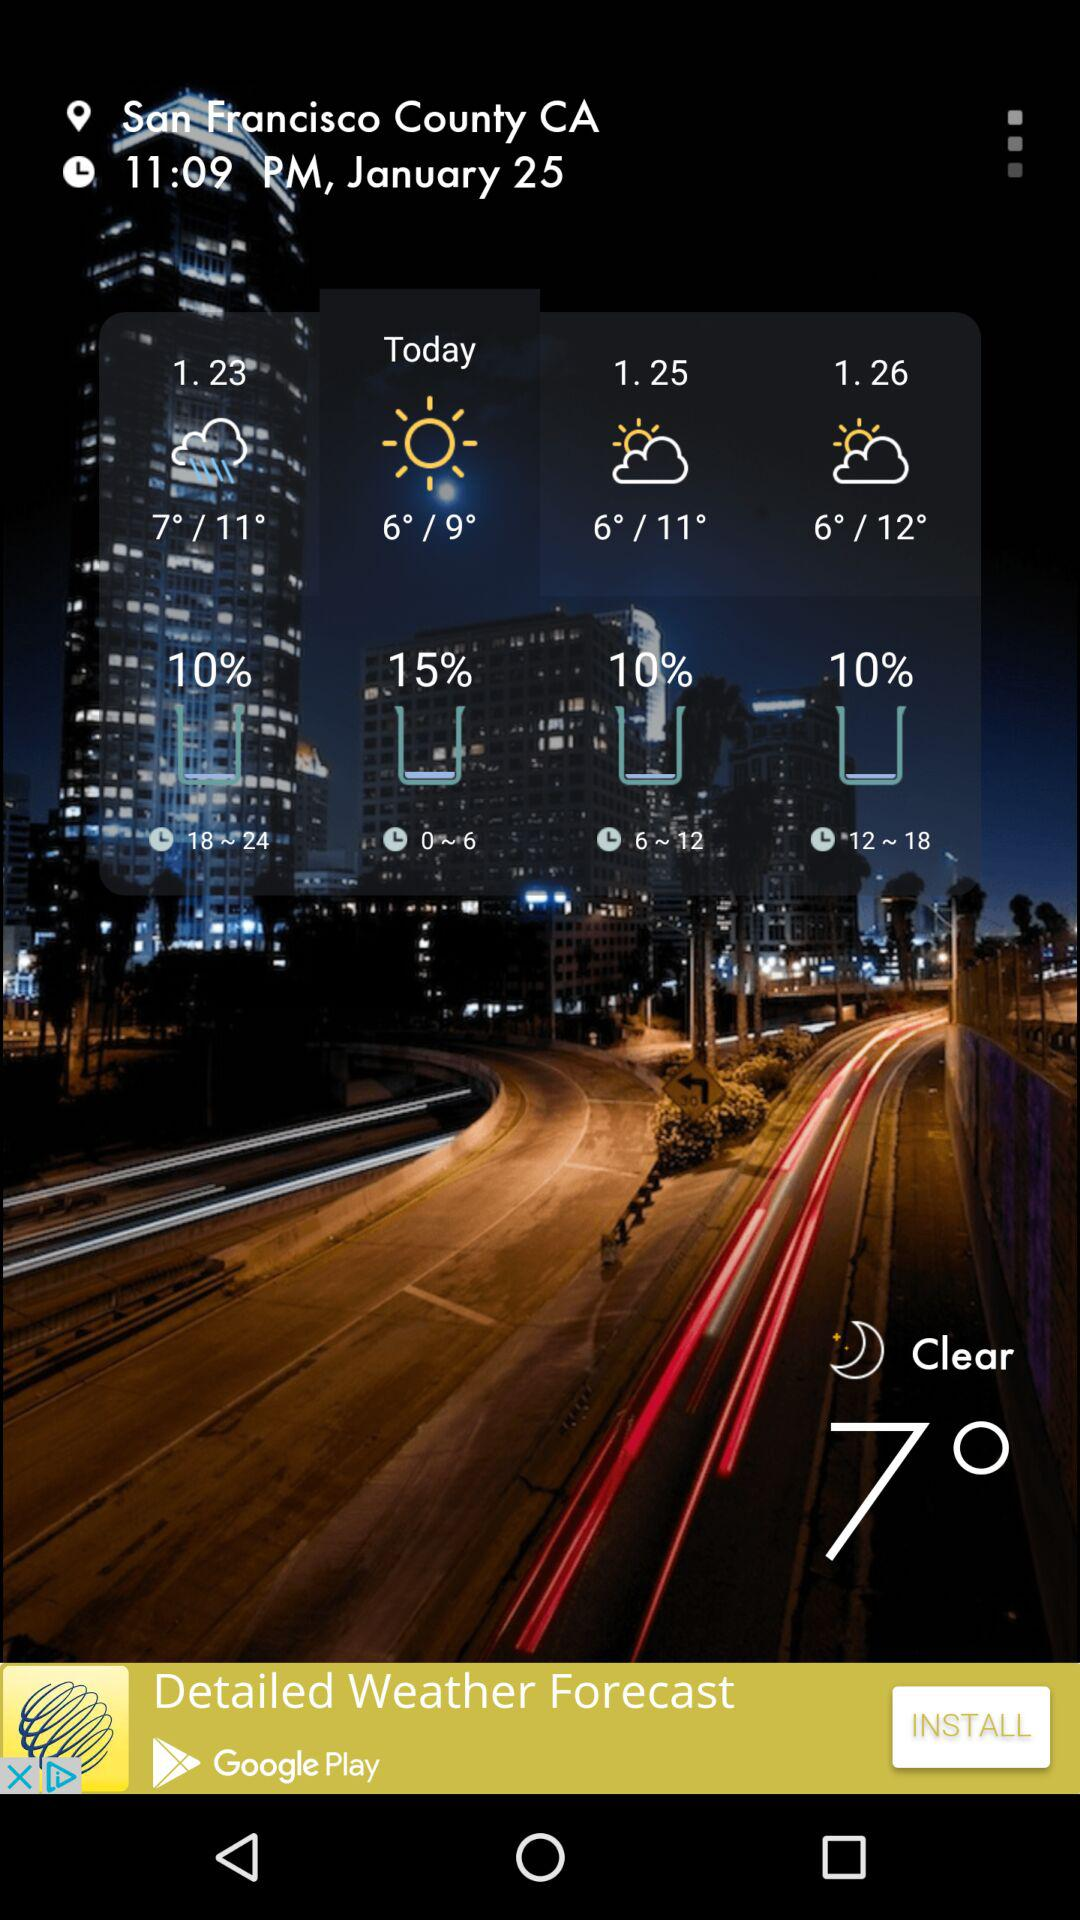At 1.23, how is the weather?
When the provided information is insufficient, respond with <no answer>. <no answer> 